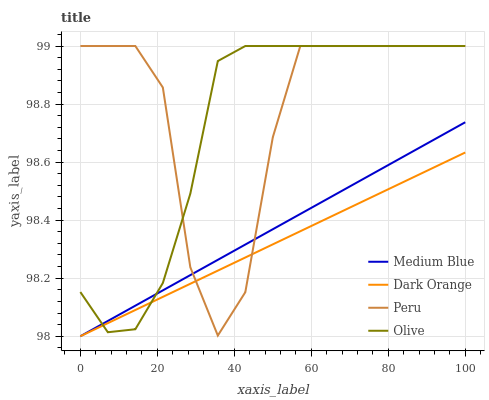Does Dark Orange have the minimum area under the curve?
Answer yes or no. Yes. Does Peru have the maximum area under the curve?
Answer yes or no. Yes. Does Medium Blue have the minimum area under the curve?
Answer yes or no. No. Does Medium Blue have the maximum area under the curve?
Answer yes or no. No. Is Dark Orange the smoothest?
Answer yes or no. Yes. Is Peru the roughest?
Answer yes or no. Yes. Is Medium Blue the smoothest?
Answer yes or no. No. Is Medium Blue the roughest?
Answer yes or no. No. Does Peru have the lowest value?
Answer yes or no. No. Does Peru have the highest value?
Answer yes or no. Yes. Does Medium Blue have the highest value?
Answer yes or no. No. Does Dark Orange intersect Peru?
Answer yes or no. Yes. Is Dark Orange less than Peru?
Answer yes or no. No. Is Dark Orange greater than Peru?
Answer yes or no. No. 